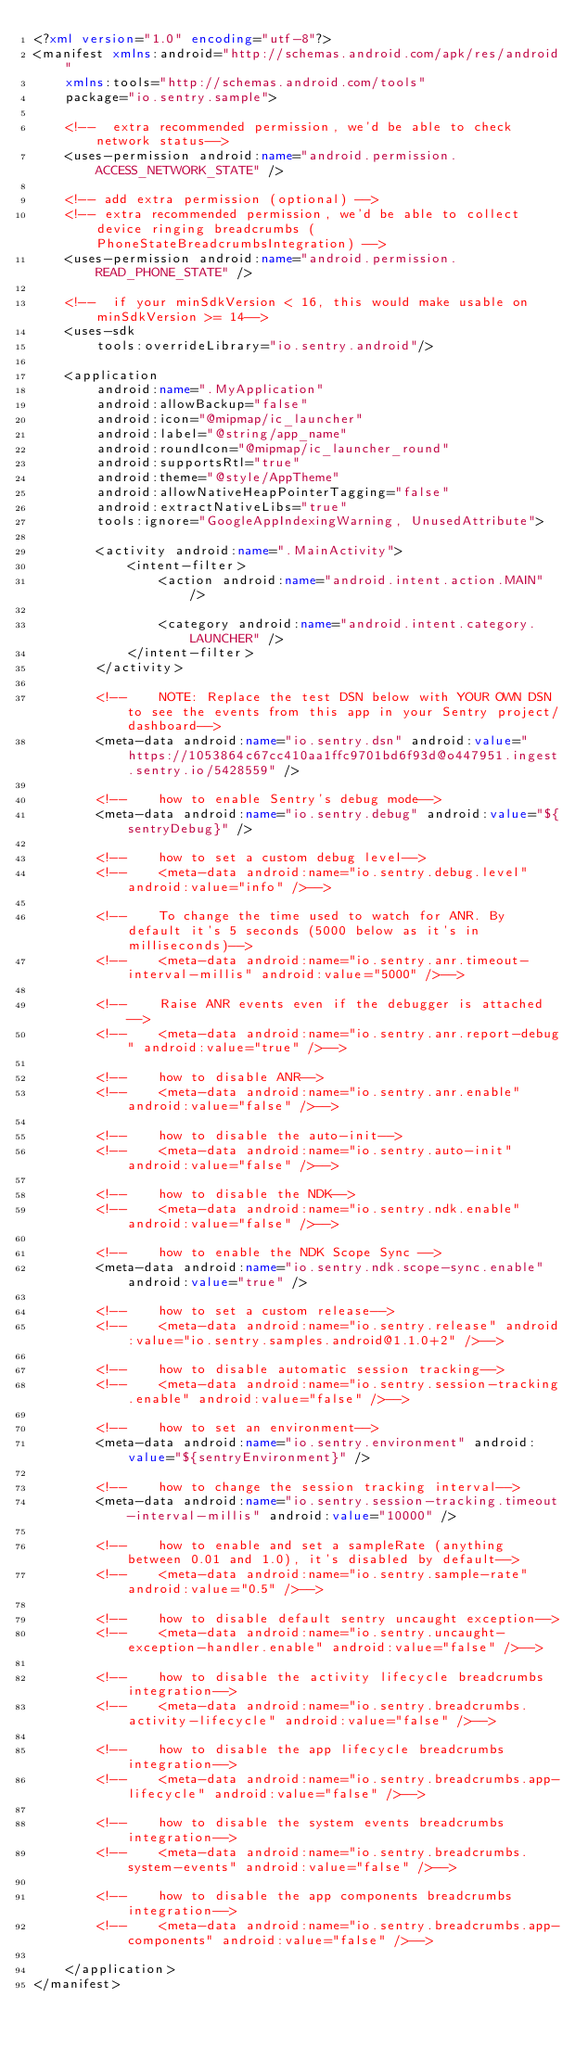<code> <loc_0><loc_0><loc_500><loc_500><_XML_><?xml version="1.0" encoding="utf-8"?>
<manifest xmlns:android="http://schemas.android.com/apk/res/android"
    xmlns:tools="http://schemas.android.com/tools"
    package="io.sentry.sample">

    <!--  extra recommended permission, we'd be able to check network status-->
    <uses-permission android:name="android.permission.ACCESS_NETWORK_STATE" />

    <!-- add extra permission (optional) -->
    <!-- extra recommended permission, we'd be able to collect device ringing breadcrumbs (PhoneStateBreadcrumbsIntegration) -->
    <uses-permission android:name="android.permission.READ_PHONE_STATE" />

    <!--  if your minSdkVersion < 16, this would make usable on minSdkVersion >= 14-->
    <uses-sdk
        tools:overrideLibrary="io.sentry.android"/>

    <application
        android:name=".MyApplication"
        android:allowBackup="false"
        android:icon="@mipmap/ic_launcher"
        android:label="@string/app_name"
        android:roundIcon="@mipmap/ic_launcher_round"
        android:supportsRtl="true"
        android:theme="@style/AppTheme"
        android:allowNativeHeapPointerTagging="false"
        android:extractNativeLibs="true"
        tools:ignore="GoogleAppIndexingWarning, UnusedAttribute">

        <activity android:name=".MainActivity">
            <intent-filter>
                <action android:name="android.intent.action.MAIN" />

                <category android:name="android.intent.category.LAUNCHER" />
            </intent-filter>
        </activity>

        <!--    NOTE: Replace the test DSN below with YOUR OWN DSN to see the events from this app in your Sentry project/dashboard-->
        <meta-data android:name="io.sentry.dsn" android:value="https://1053864c67cc410aa1ffc9701bd6f93d@o447951.ingest.sentry.io/5428559" />

        <!--    how to enable Sentry's debug mode-->
        <meta-data android:name="io.sentry.debug" android:value="${sentryDebug}" />

        <!--    how to set a custom debug level-->
        <!--    <meta-data android:name="io.sentry.debug.level" android:value="info" />-->

        <!--    To change the time used to watch for ANR. By default it's 5 seconds (5000 below as it's in milliseconds)-->
        <!--    <meta-data android:name="io.sentry.anr.timeout-interval-millis" android:value="5000" />-->

        <!--    Raise ANR events even if the debugger is attached-->
        <!--    <meta-data android:name="io.sentry.anr.report-debug" android:value="true" />-->

        <!--    how to disable ANR-->
        <!--    <meta-data android:name="io.sentry.anr.enable" android:value="false" />-->

        <!--    how to disable the auto-init-->
        <!--    <meta-data android:name="io.sentry.auto-init" android:value="false" />-->

        <!--    how to disable the NDK-->
        <!--    <meta-data android:name="io.sentry.ndk.enable" android:value="false" />-->

        <!--    how to enable the NDK Scope Sync -->
        <meta-data android:name="io.sentry.ndk.scope-sync.enable" android:value="true" />

        <!--    how to set a custom release-->
        <!--    <meta-data android:name="io.sentry.release" android:value="io.sentry.samples.android@1.1.0+2" />-->

        <!--    how to disable automatic session tracking-->
        <!--    <meta-data android:name="io.sentry.session-tracking.enable" android:value="false" />-->

        <!--    how to set an environment-->
        <meta-data android:name="io.sentry.environment" android:value="${sentryEnvironment}" />

        <!--    how to change the session tracking interval-->
        <meta-data android:name="io.sentry.session-tracking.timeout-interval-millis" android:value="10000" />

        <!--    how to enable and set a sampleRate (anything between 0.01 and 1.0), it's disabled by default-->
        <!--    <meta-data android:name="io.sentry.sample-rate" android:value="0.5" />-->

        <!--    how to disable default sentry uncaught exception-->
        <!--    <meta-data android:name="io.sentry.uncaught-exception-handler.enable" android:value="false" />-->

        <!--    how to disable the activity lifecycle breadcrumbs integration-->
        <!--    <meta-data android:name="io.sentry.breadcrumbs.activity-lifecycle" android:value="false" />-->

        <!--    how to disable the app lifecycle breadcrumbs integration-->
        <!--    <meta-data android:name="io.sentry.breadcrumbs.app-lifecycle" android:value="false" />-->

        <!--    how to disable the system events breadcrumbs integration-->
        <!--    <meta-data android:name="io.sentry.breadcrumbs.system-events" android:value="false" />-->

        <!--    how to disable the app components breadcrumbs integration-->
        <!--    <meta-data android:name="io.sentry.breadcrumbs.app-components" android:value="false" />-->

    </application>
</manifest>
</code> 